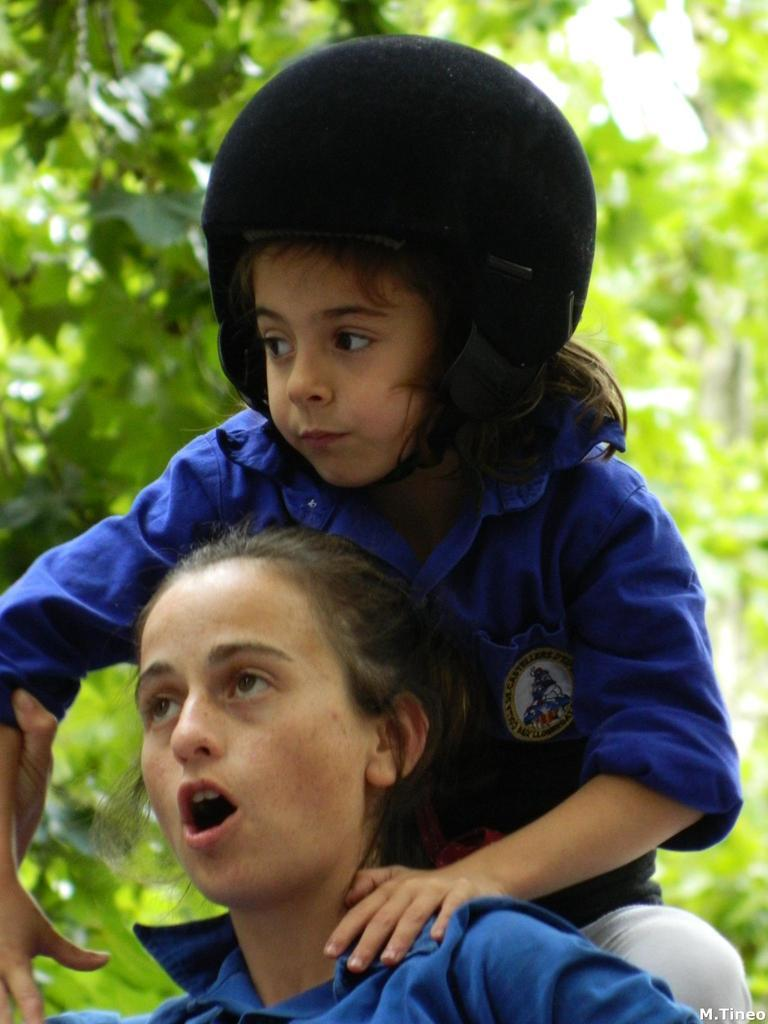Who or what is present in the image? There are people in the image. What are the people wearing? The people are wearing blue dresses. What can be seen in the background of the image? There are trees in the background of the image. What type of wire is being used by the people in the image? There is no wire present in the image. What flavor of soda is being consumed by the people in the image? There is no soda present in the image. 